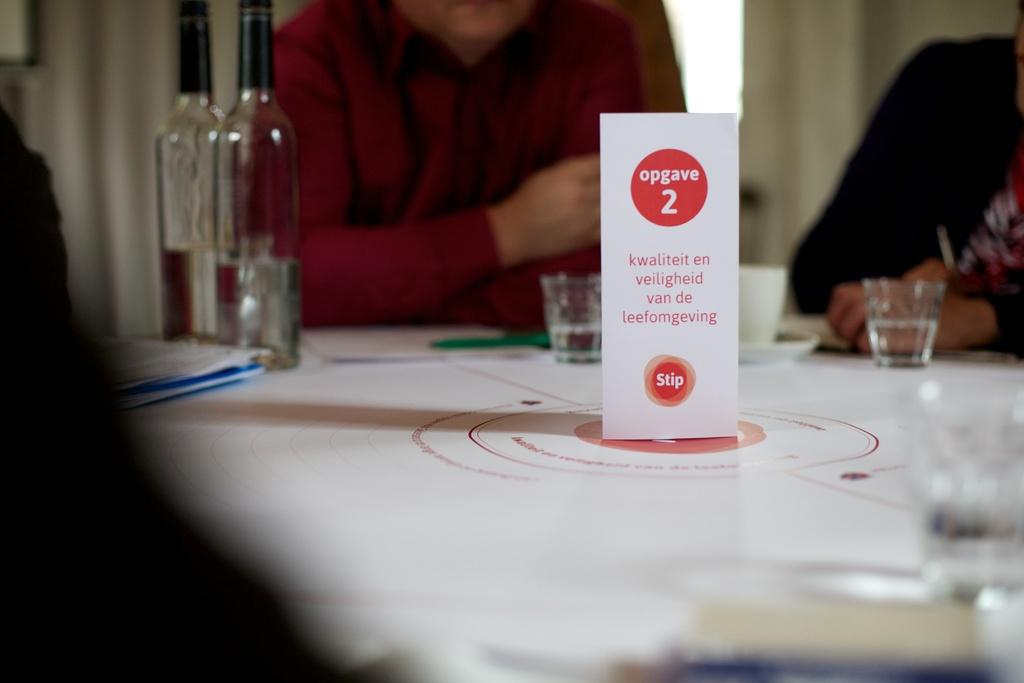What is on the table in the image? There is a paper, bottles, and glasses on the table. Who is present around the table? There are people sitting around the table. What type of street can be seen in the image? There is no street visible in the image; it features a table with objects and people sitting around it. What kind of list is being discussed by the people around the table? There is no list mentioned or visible in the image. 